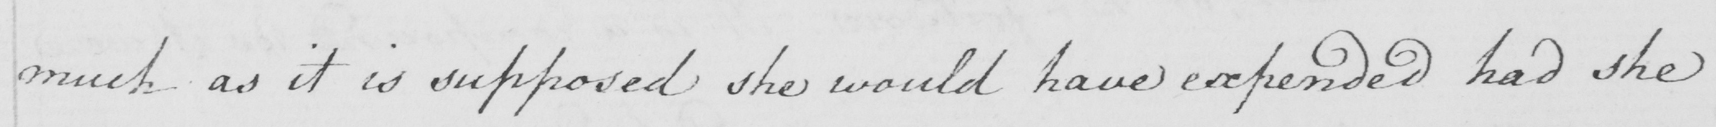Can you read and transcribe this handwriting? much as it is supposed she would have expended had she 